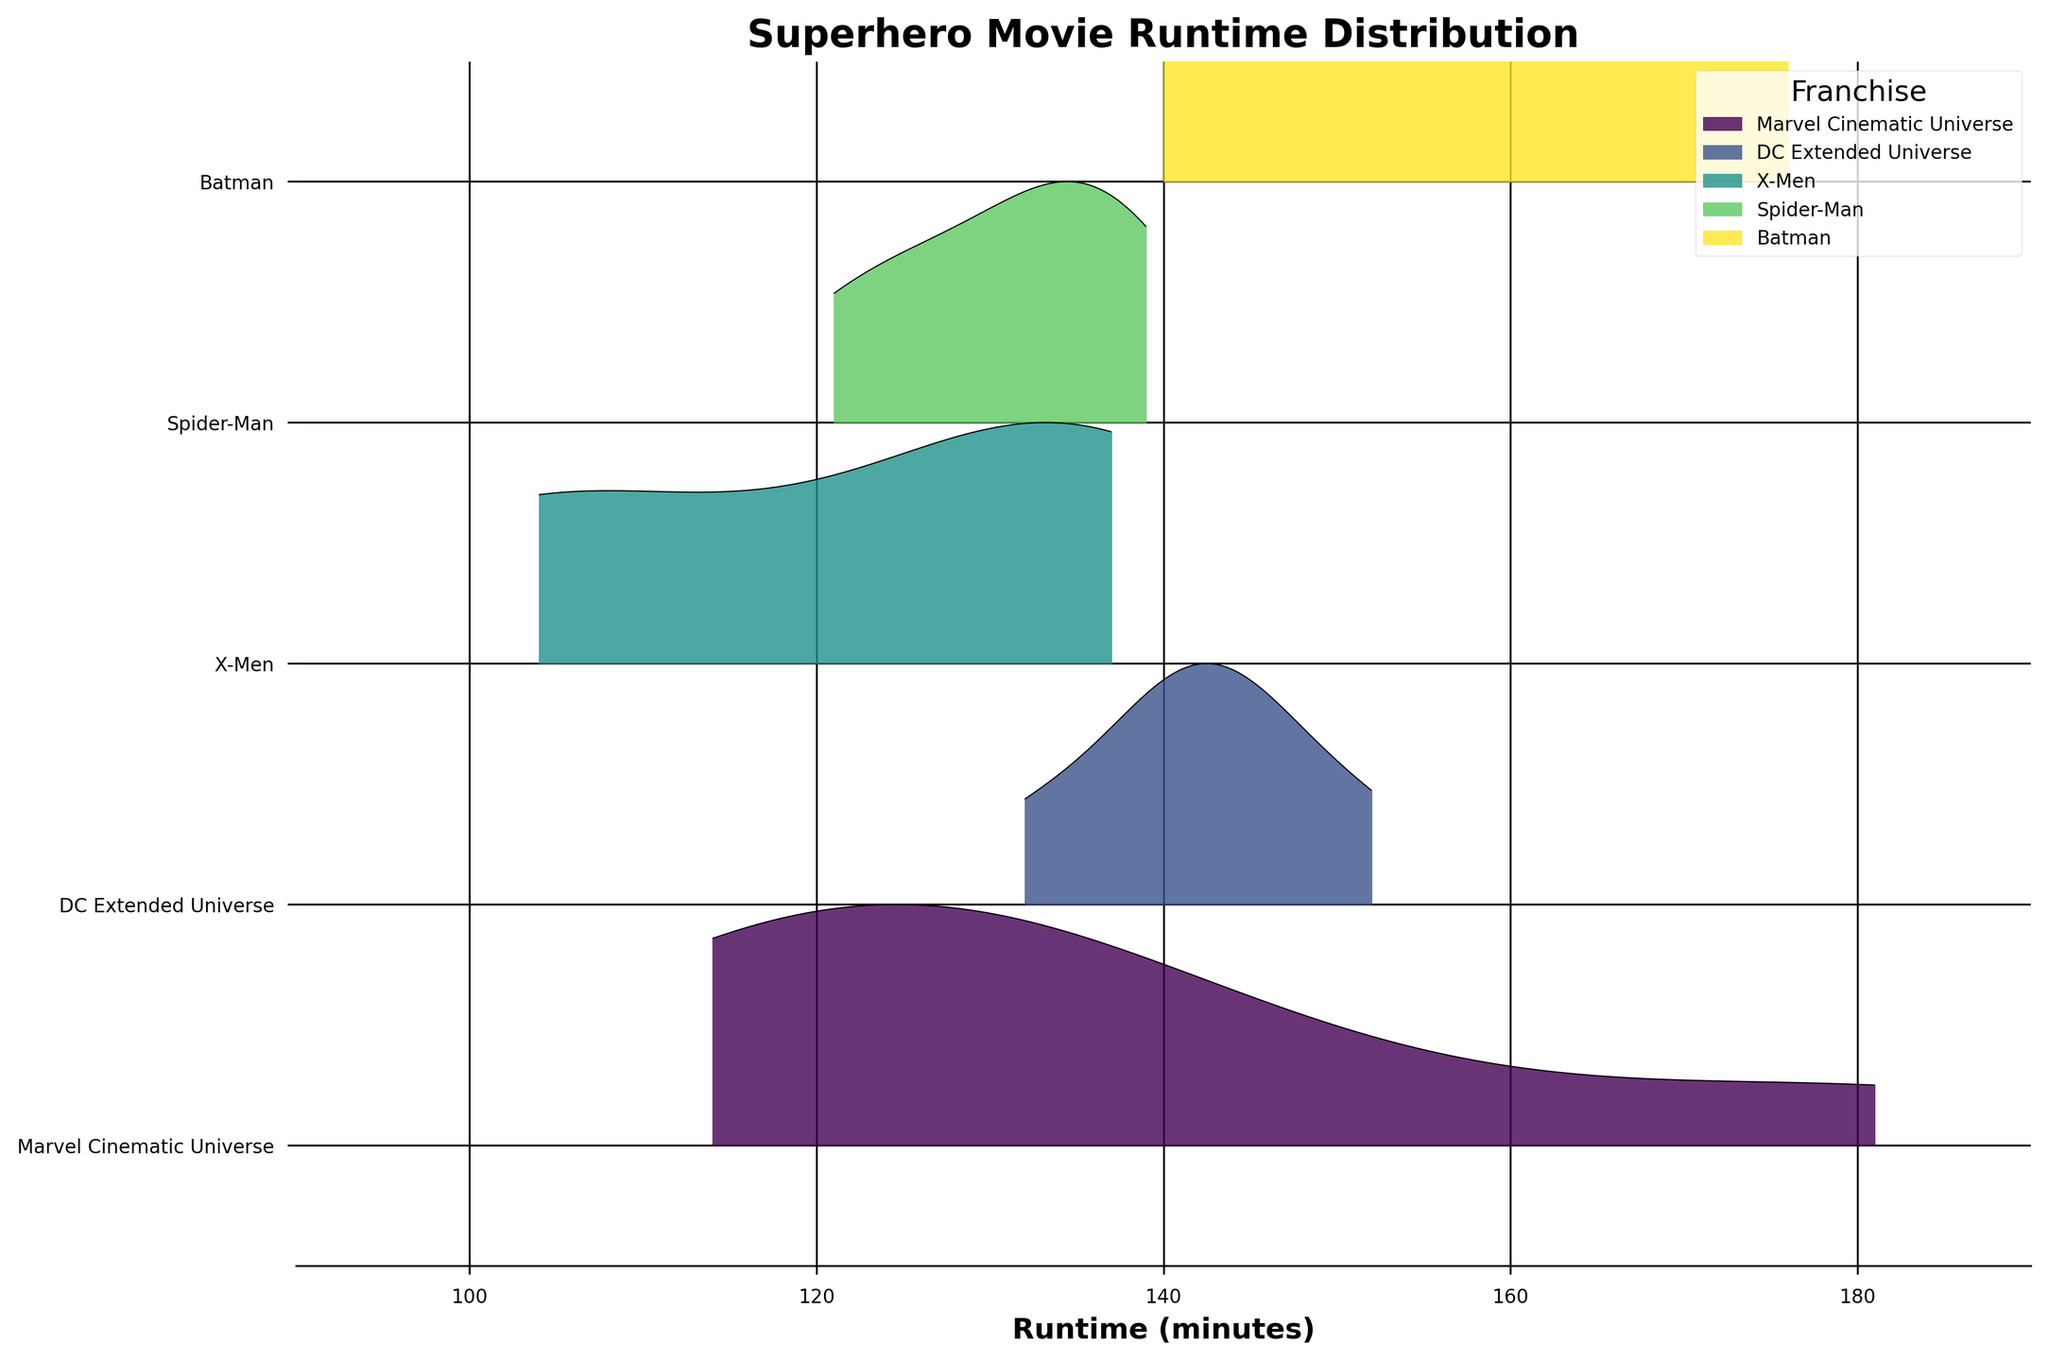What's the title of the figure? The title is displayed at the top of the plot area, indicating the main subject of the figure. Reading the title provides insight into what the figure represents.
Answer: Superhero Movie Runtime Distribution How many movie franchises are compared in the plot? The number of unique items on the y-axis represents the number of movie franchises. Count the labels from top to bottom.
Answer: 5 Which franchise has the longest runtime movie? Identify the franchise with the peak reaching the farthest right on the x-axis. This represents the movie with the longest runtime within that franchise.
Answer: Marvel Cinematic Universe What's the color scheme used to differentiate the franchises? The plot uses a color gradient to differentiate between franchises. Look for varying colors filling the ridge plots.
Answer: A gradient from light to dark green Which franchise shows the smallest range of movie runtimes? The range of movie runtimes is visually represented by the width of the distribution curve. The franchise with the narrowest distribution curve has the smallest range.
Answer: X-Men Compare the median runtimes of the Marvel Cinematic Universe and the DC Extended Universe. Which is greater? The median runtimes can be approximated by locating the central peak of each respective franchise's distribution. Compare the approximate midpoints of these peaks.
Answer: Marvel Cinematic Universe What is the most common runtime interval for Spider-Man movies? The highest point of the distribution in the Spider-Man ridgeline plot indicates the most common runtime interval. Find the tallest part of the curve and note the range on the x-axis.
Answer: Between 120 and 130 minutes Which franchise's movies generally have a runtime greater than 140 minutes? Identify the franchises with a significant portion of their ridge plots lying to the right of the 140-minute mark on the x-axis.
Answer: Batman and Marvel Cinematic Universe Which two franchises have a noticeable peak around 143 minutes? Look at the distribution curves to find peaks close to the 143-minute mark and identify the corresponding franchises on the y-axis.
Answer: DC Extended Universe and Marvel Cinematic Universe 